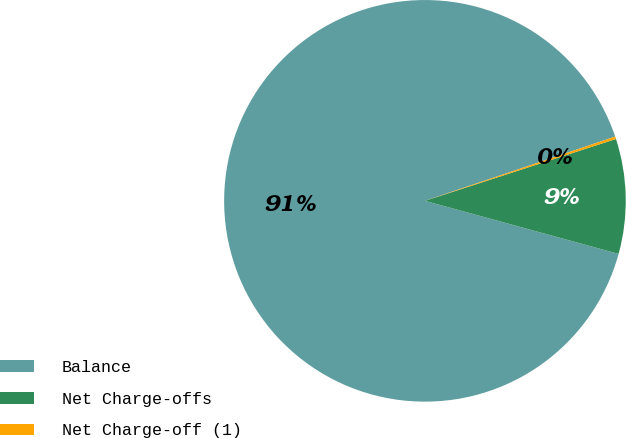Convert chart to OTSL. <chart><loc_0><loc_0><loc_500><loc_500><pie_chart><fcel>Balance<fcel>Net Charge-offs<fcel>Net Charge-off (1)<nl><fcel>90.56%<fcel>9.24%<fcel>0.2%<nl></chart> 